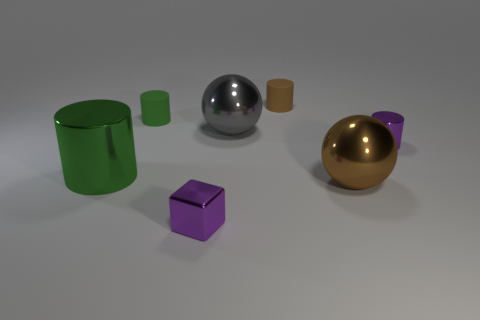The tiny object that is the same color as the cube is what shape?
Your response must be concise. Cylinder. How many things are either green metallic cylinders or tiny cyan cylinders?
Provide a succinct answer. 1. Are there any large yellow cylinders made of the same material as the gray thing?
Your answer should be compact. No. What color is the big ball that is in front of the small purple thing to the right of the brown rubber thing?
Make the answer very short. Brown. Do the purple metal cylinder and the brown metal sphere have the same size?
Provide a short and direct response. No. How many balls are cyan metallic objects or gray objects?
Your response must be concise. 1. There is a small purple metallic object that is on the left side of the brown matte thing; what number of small green rubber things are in front of it?
Provide a succinct answer. 0. Is the shape of the large gray shiny object the same as the large brown metallic object?
Provide a short and direct response. Yes. What size is the gray thing that is the same shape as the large brown metallic object?
Provide a succinct answer. Large. What shape is the tiny purple shiny object on the right side of the tiny metallic object that is in front of the big brown ball?
Offer a very short reply. Cylinder. 